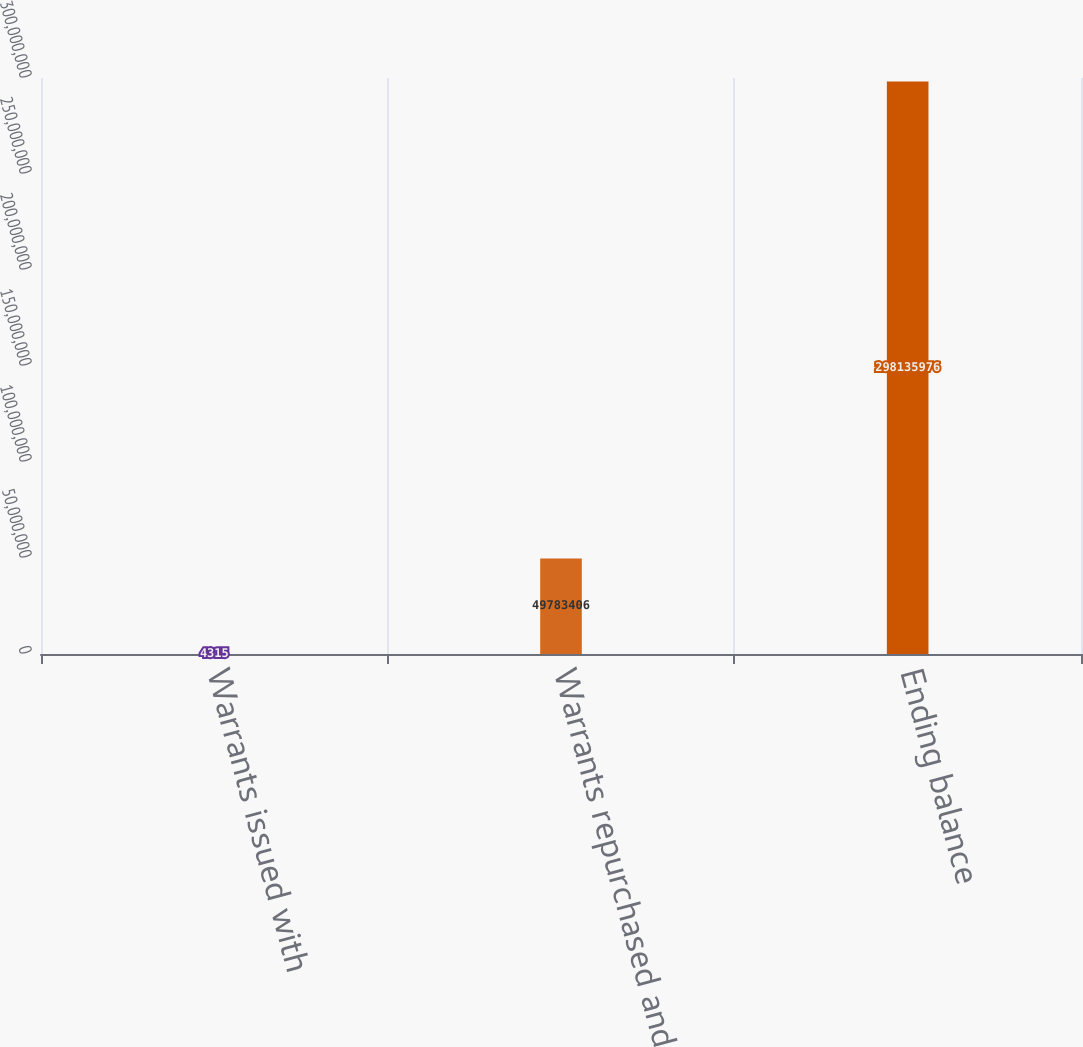Convert chart to OTSL. <chart><loc_0><loc_0><loc_500><loc_500><bar_chart><fcel>Warrants issued with<fcel>Warrants repurchased and<fcel>Ending balance<nl><fcel>4315<fcel>4.97834e+07<fcel>2.98136e+08<nl></chart> 